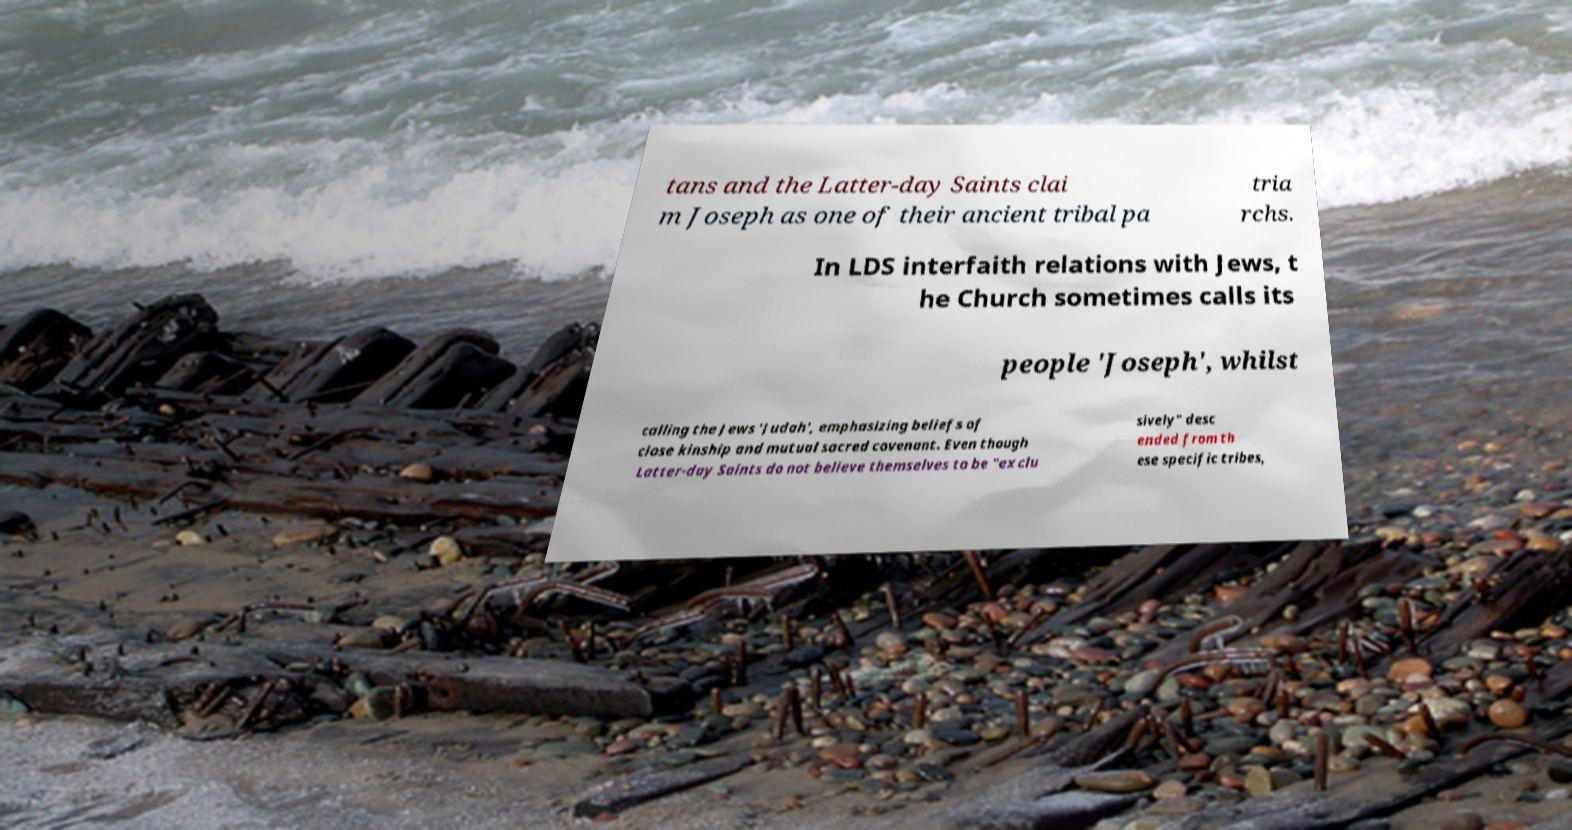Please read and relay the text visible in this image. What does it say? tans and the Latter-day Saints clai m Joseph as one of their ancient tribal pa tria rchs. In LDS interfaith relations with Jews, t he Church sometimes calls its people 'Joseph', whilst calling the Jews 'Judah', emphasizing beliefs of close kinship and mutual sacred covenant. Even though Latter-day Saints do not believe themselves to be "exclu sively" desc ended from th ese specific tribes, 